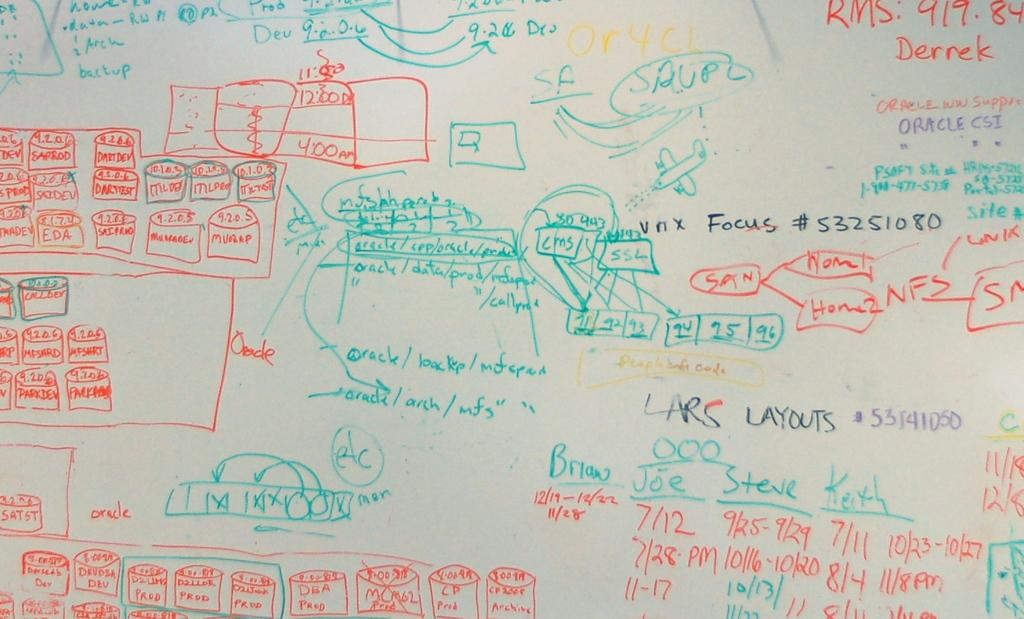What is the main subject of the image? The main subject of the image is text on a board. Can you describe the text on the board? Unfortunately, the specific content of the text cannot be determined from the provided facts. Is there any other object or element in the image besides the board with text? The provided facts do not mention any other objects or elements in the image. How many quarters can be seen on the board in the image? There is no mention of quarters in the image, as the main subject is text on a board. 